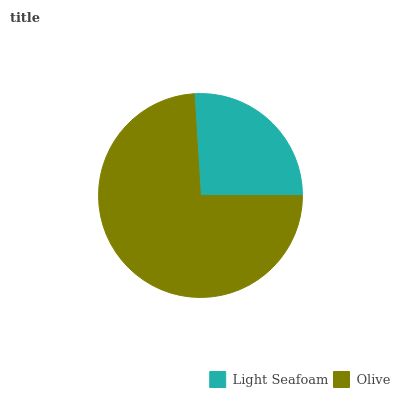Is Light Seafoam the minimum?
Answer yes or no. Yes. Is Olive the maximum?
Answer yes or no. Yes. Is Olive the minimum?
Answer yes or no. No. Is Olive greater than Light Seafoam?
Answer yes or no. Yes. Is Light Seafoam less than Olive?
Answer yes or no. Yes. Is Light Seafoam greater than Olive?
Answer yes or no. No. Is Olive less than Light Seafoam?
Answer yes or no. No. Is Olive the high median?
Answer yes or no. Yes. Is Light Seafoam the low median?
Answer yes or no. Yes. Is Light Seafoam the high median?
Answer yes or no. No. Is Olive the low median?
Answer yes or no. No. 